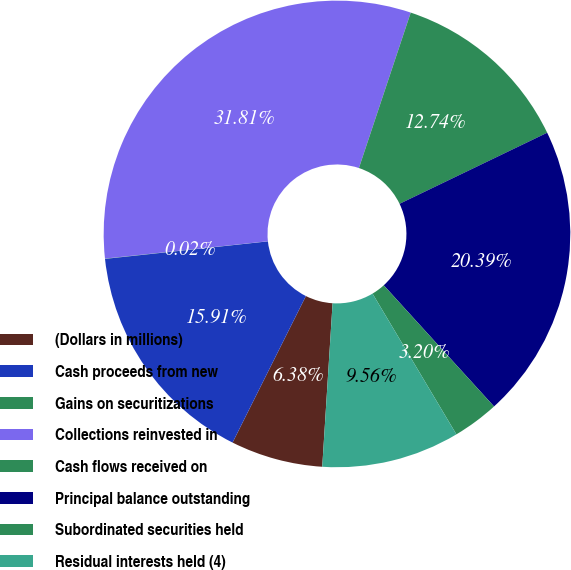Convert chart. <chart><loc_0><loc_0><loc_500><loc_500><pie_chart><fcel>(Dollars in millions)<fcel>Cash proceeds from new<fcel>Gains on securitizations<fcel>Collections reinvested in<fcel>Cash flows received on<fcel>Principal balance outstanding<fcel>Subordinated securities held<fcel>Residual interests held (4)<nl><fcel>6.38%<fcel>15.91%<fcel>0.02%<fcel>31.81%<fcel>12.74%<fcel>20.39%<fcel>3.2%<fcel>9.56%<nl></chart> 